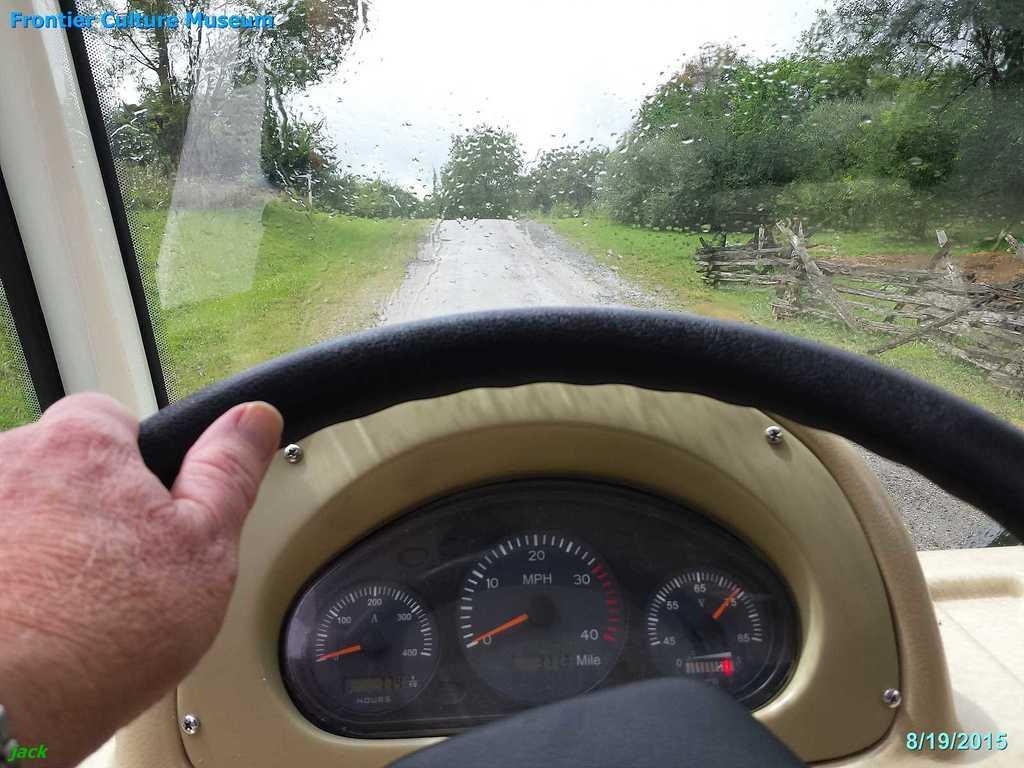How would you summarize this image in a sentence or two? In the center of the image we can see steering, indicator, person's leg and hand. In the background there is a mirror, trees, road and sky. 